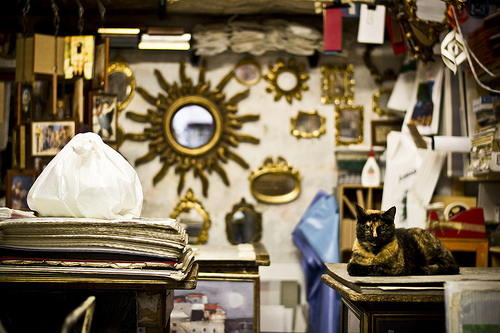<image>
Can you confirm if the cat is on the table? Yes. Looking at the image, I can see the cat is positioned on top of the table, with the table providing support. Is the mirror under the ribbons? Yes. The mirror is positioned underneath the ribbons, with the ribbons above it in the vertical space. 